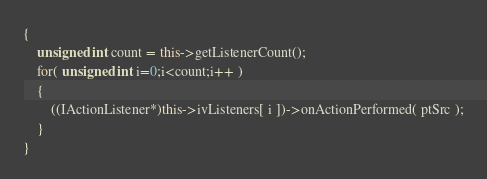Convert code to text. <code><loc_0><loc_0><loc_500><loc_500><_C++_>{
	unsigned int count = this->getListenerCount();
	for( unsigned int i=0;i<count;i++ )
	{
		((IActionListener*)this->ivListeners[ i ])->onActionPerformed( ptSrc );
	}
}</code> 